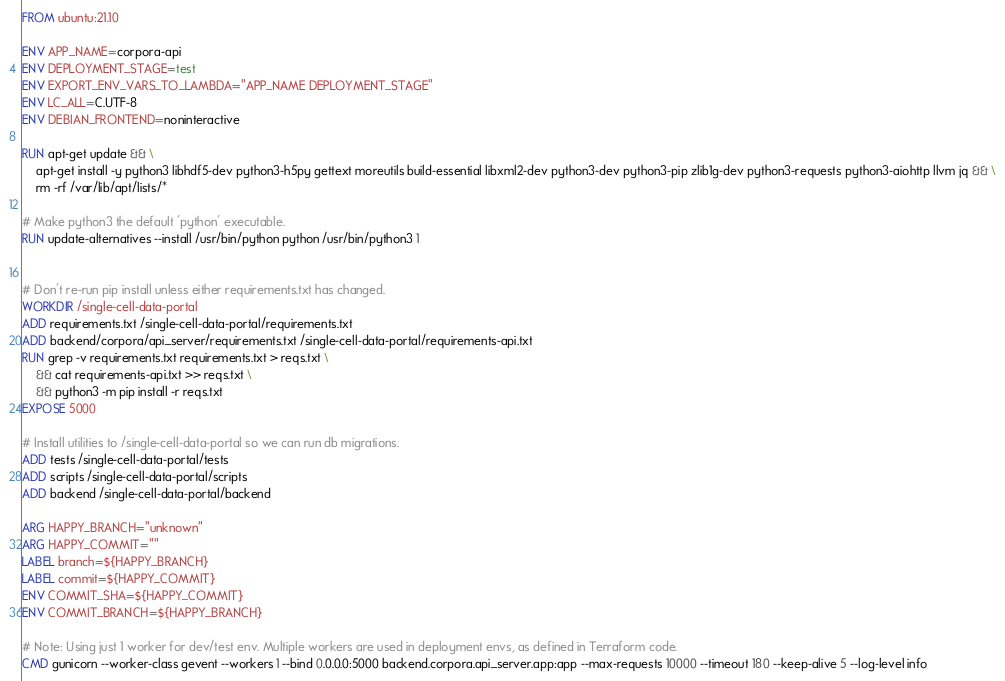Convert code to text. <code><loc_0><loc_0><loc_500><loc_500><_Dockerfile_>FROM ubuntu:21.10

ENV APP_NAME=corpora-api
ENV DEPLOYMENT_STAGE=test
ENV EXPORT_ENV_VARS_TO_LAMBDA="APP_NAME DEPLOYMENT_STAGE"
ENV LC_ALL=C.UTF-8
ENV DEBIAN_FRONTEND=noninteractive

RUN apt-get update && \
    apt-get install -y python3 libhdf5-dev python3-h5py gettext moreutils build-essential libxml2-dev python3-dev python3-pip zlib1g-dev python3-requests python3-aiohttp llvm jq && \
    rm -rf /var/lib/apt/lists/*

# Make python3 the default 'python' executable.
RUN update-alternatives --install /usr/bin/python python /usr/bin/python3 1


# Don't re-run pip install unless either requirements.txt has changed.
WORKDIR /single-cell-data-portal
ADD requirements.txt /single-cell-data-portal/requirements.txt
ADD backend/corpora/api_server/requirements.txt /single-cell-data-portal/requirements-api.txt
RUN grep -v requirements.txt requirements.txt > reqs.txt \
    && cat requirements-api.txt >> reqs.txt \
    && python3 -m pip install -r reqs.txt
EXPOSE 5000

# Install utilities to /single-cell-data-portal so we can run db migrations.
ADD tests /single-cell-data-portal/tests
ADD scripts /single-cell-data-portal/scripts
ADD backend /single-cell-data-portal/backend

ARG HAPPY_BRANCH="unknown"
ARG HAPPY_COMMIT=""
LABEL branch=${HAPPY_BRANCH}
LABEL commit=${HAPPY_COMMIT}
ENV COMMIT_SHA=${HAPPY_COMMIT}
ENV COMMIT_BRANCH=${HAPPY_BRANCH}

# Note: Using just 1 worker for dev/test env. Multiple workers are used in deployment envs, as defined in Terraform code.
CMD gunicorn --worker-class gevent --workers 1 --bind 0.0.0.0:5000 backend.corpora.api_server.app:app --max-requests 10000 --timeout 180 --keep-alive 5 --log-level info
</code> 